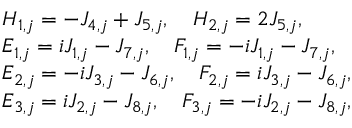Convert formula to latex. <formula><loc_0><loc_0><loc_500><loc_500>\begin{array} { r l } & { H _ { 1 , j } = - J _ { 4 , j } + J _ { 5 , j } , \quad H _ { 2 , j } = 2 J _ { 5 , j } , } \\ & { E _ { 1 , j } = i J _ { 1 , j } - J _ { 7 , j } , \quad F _ { 1 , j } = - i J _ { 1 , j } - J _ { 7 , j } , } \\ & { E _ { 2 , j } = - i J _ { 3 , j } - J _ { 6 , j } , \quad F _ { 2 , j } = i J _ { 3 , j } - J _ { 6 , j } , } \\ & { E _ { 3 , j } = i J _ { 2 , j } - J _ { 8 , j } , \quad F _ { 3 , j } = - i J _ { 2 , j } - J _ { 8 , j } , } \end{array}</formula> 